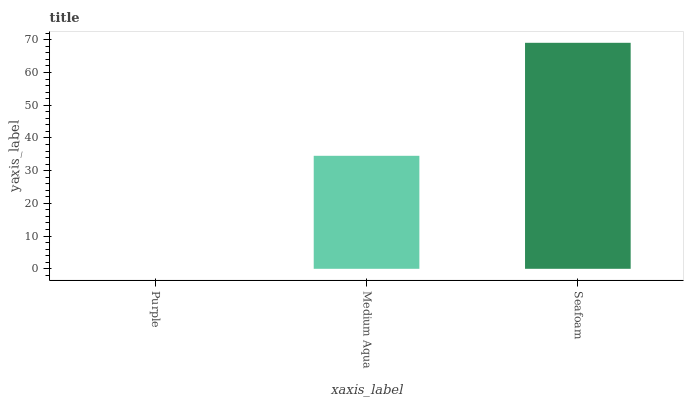Is Purple the minimum?
Answer yes or no. Yes. Is Seafoam the maximum?
Answer yes or no. Yes. Is Medium Aqua the minimum?
Answer yes or no. No. Is Medium Aqua the maximum?
Answer yes or no. No. Is Medium Aqua greater than Purple?
Answer yes or no. Yes. Is Purple less than Medium Aqua?
Answer yes or no. Yes. Is Purple greater than Medium Aqua?
Answer yes or no. No. Is Medium Aqua less than Purple?
Answer yes or no. No. Is Medium Aqua the high median?
Answer yes or no. Yes. Is Medium Aqua the low median?
Answer yes or no. Yes. Is Seafoam the high median?
Answer yes or no. No. Is Seafoam the low median?
Answer yes or no. No. 